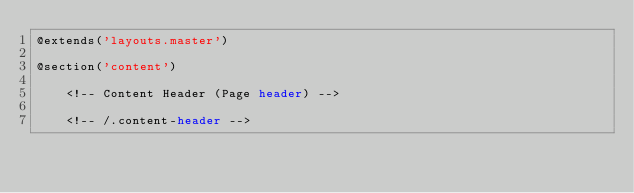<code> <loc_0><loc_0><loc_500><loc_500><_PHP_>@extends('layouts.master')

@section('content')

    <!-- Content Header (Page header) -->
    
    <!-- /.content-header -->
</code> 